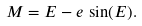Convert formula to latex. <formula><loc_0><loc_0><loc_500><loc_500>M = E - e \, \sin ( E ) .</formula> 